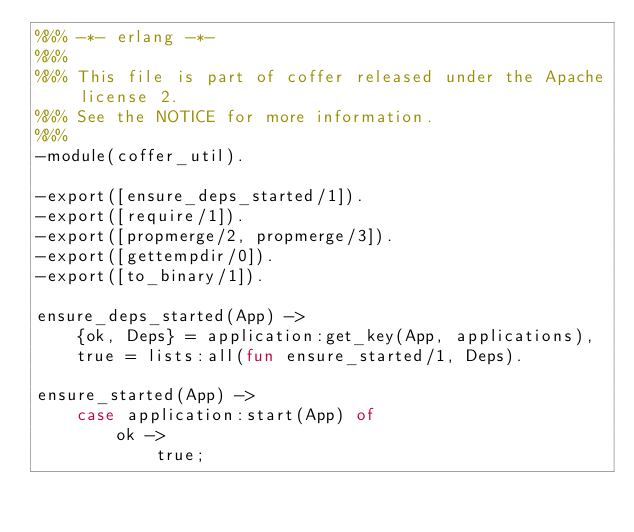Convert code to text. <code><loc_0><loc_0><loc_500><loc_500><_Erlang_>%%% -*- erlang -*-
%%%
%%% This file is part of coffer released under the Apache license 2.
%%% See the NOTICE for more information.
%%%
-module(coffer_util).

-export([ensure_deps_started/1]).
-export([require/1]).
-export([propmerge/2, propmerge/3]).
-export([gettempdir/0]).
-export([to_binary/1]).

ensure_deps_started(App) ->
    {ok, Deps} = application:get_key(App, applications),
    true = lists:all(fun ensure_started/1, Deps).

ensure_started(App) ->
    case application:start(App) of
        ok ->
            true;</code> 